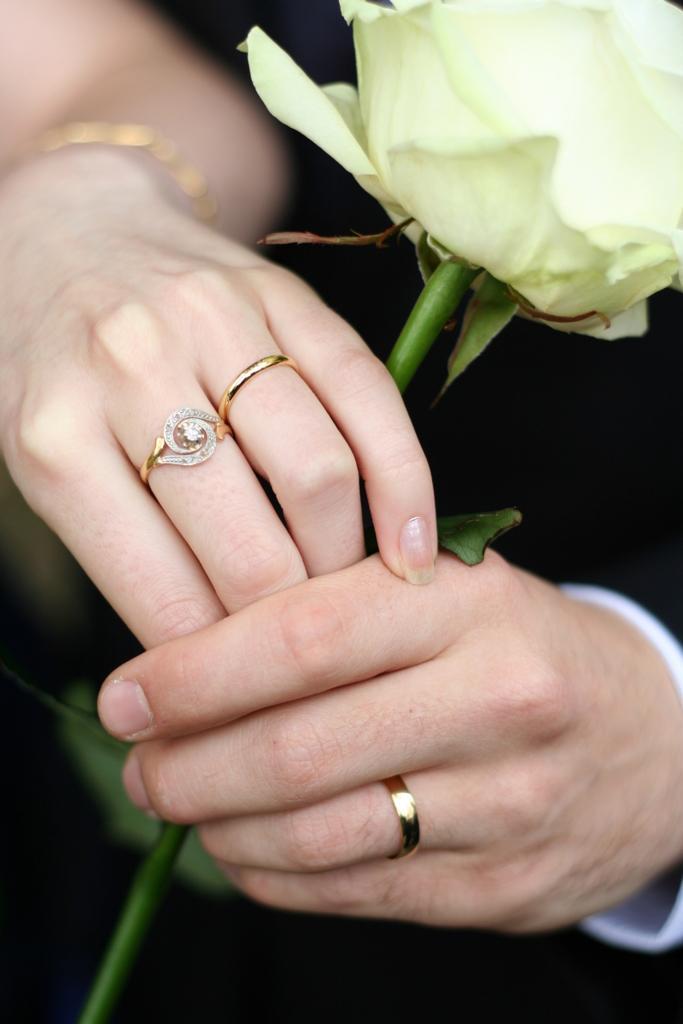How would you summarize this image in a sentence or two? In this image I can see two hands. There are three rings to the fingers. I can see a flower. 